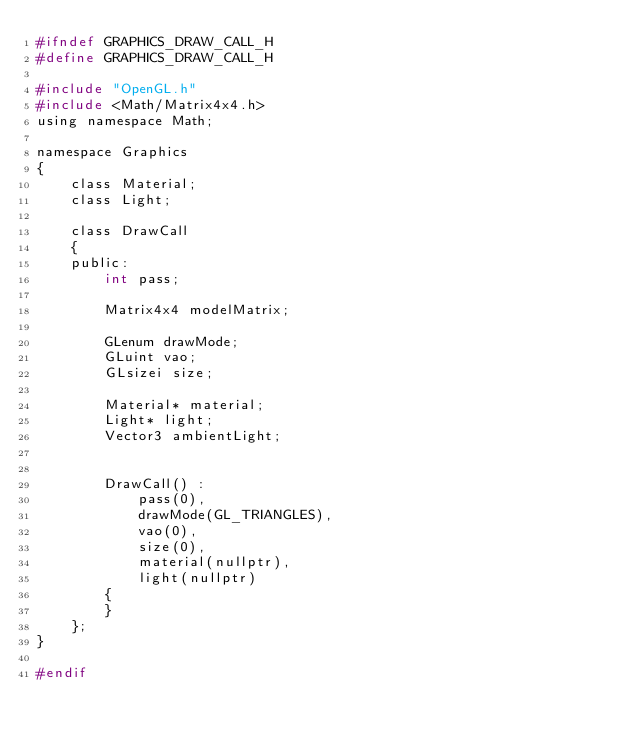Convert code to text. <code><loc_0><loc_0><loc_500><loc_500><_C_>#ifndef GRAPHICS_DRAW_CALL_H
#define GRAPHICS_DRAW_CALL_H

#include "OpenGL.h"
#include <Math/Matrix4x4.h>
using namespace Math;

namespace Graphics
{
    class Material;
    class Light;

    class DrawCall
    {
    public:
        int pass;

        Matrix4x4 modelMatrix;

        GLenum drawMode;
        GLuint vao;
        GLsizei size;

        Material* material;
        Light* light;
        Vector3 ambientLight;


        DrawCall() :
            pass(0),
            drawMode(GL_TRIANGLES),
            vao(0),
            size(0),
            material(nullptr),
            light(nullptr)
        {
        }
    };
}

#endif
</code> 